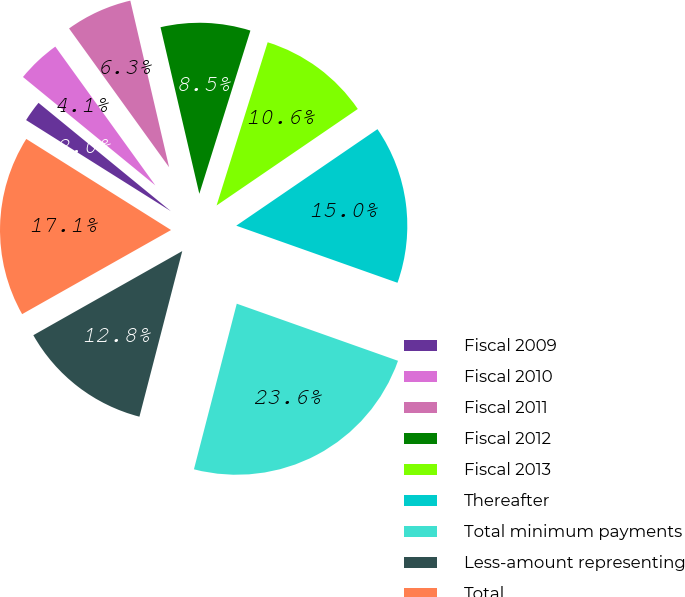Convert chart to OTSL. <chart><loc_0><loc_0><loc_500><loc_500><pie_chart><fcel>Fiscal 2009<fcel>Fiscal 2010<fcel>Fiscal 2011<fcel>Fiscal 2012<fcel>Fiscal 2013<fcel>Thereafter<fcel>Total minimum payments<fcel>Less-amount representing<fcel>Total<nl><fcel>1.98%<fcel>4.14%<fcel>6.3%<fcel>8.47%<fcel>10.63%<fcel>14.96%<fcel>23.61%<fcel>12.79%<fcel>17.12%<nl></chart> 